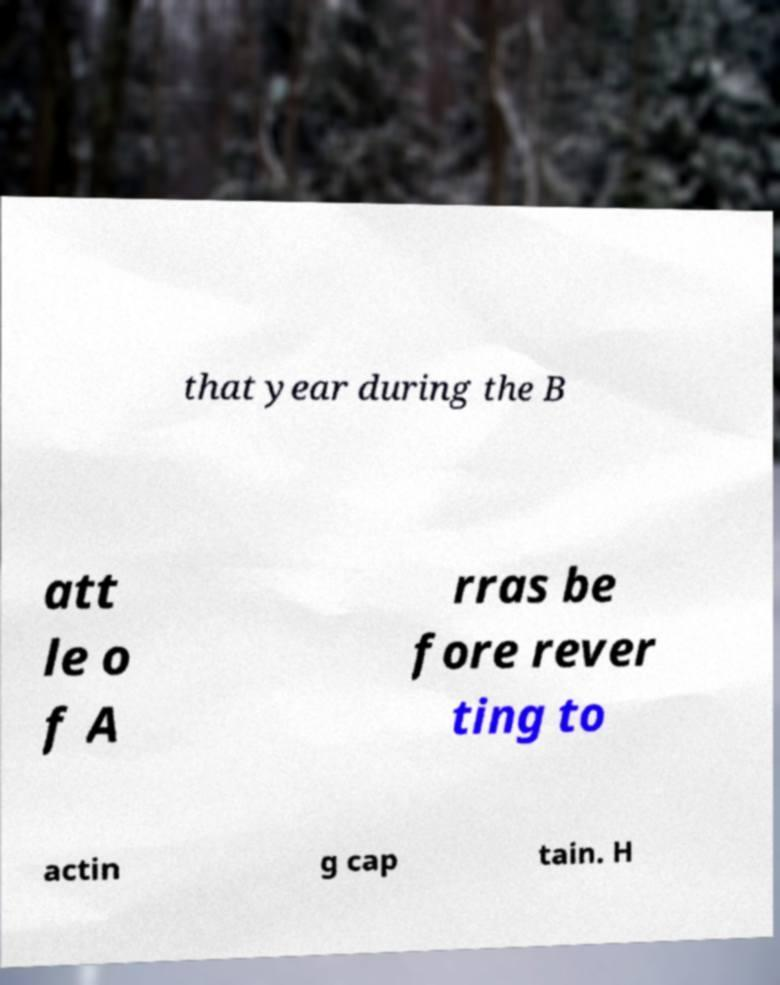Please read and relay the text visible in this image. What does it say? that year during the B att le o f A rras be fore rever ting to actin g cap tain. H 